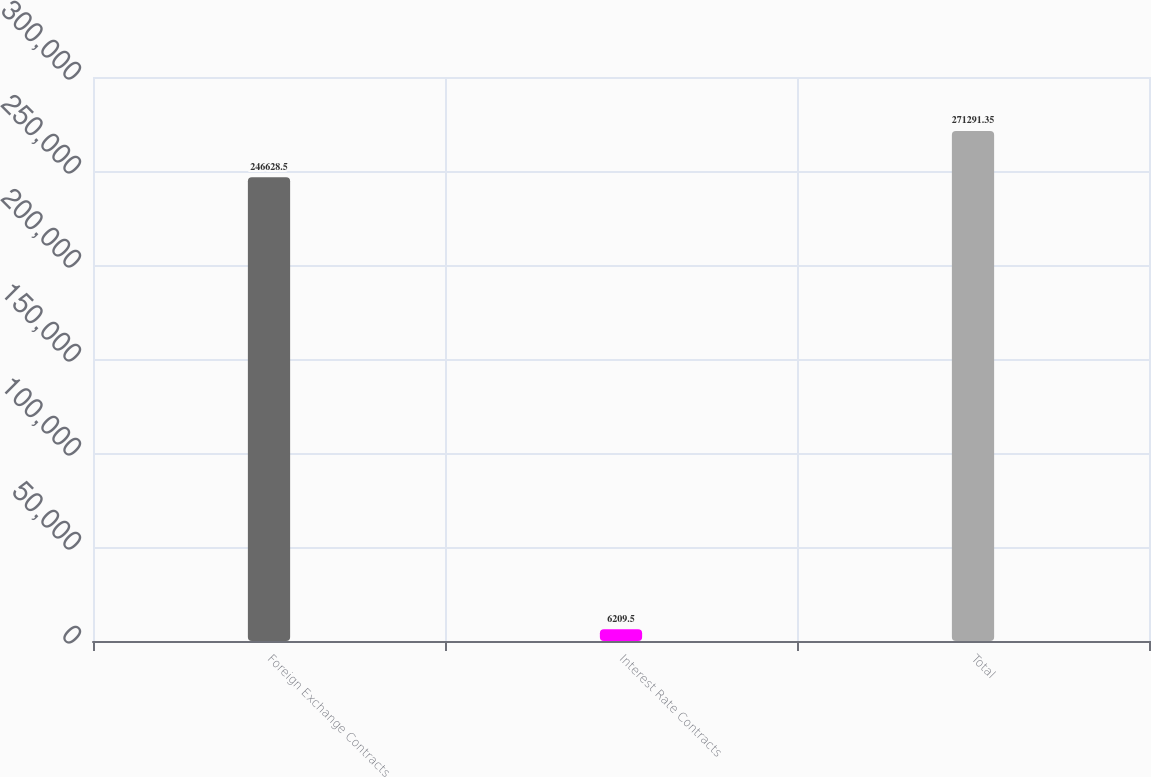<chart> <loc_0><loc_0><loc_500><loc_500><bar_chart><fcel>Foreign Exchange Contracts<fcel>Interest Rate Contracts<fcel>Total<nl><fcel>246628<fcel>6209.5<fcel>271291<nl></chart> 